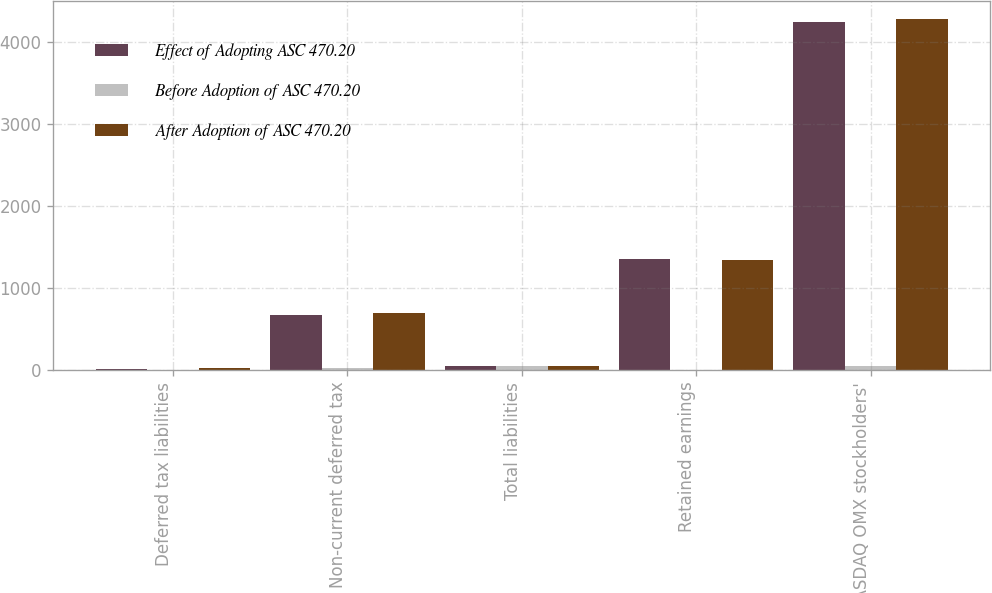Convert chart to OTSL. <chart><loc_0><loc_0><loc_500><loc_500><stacked_bar_chart><ecel><fcel>Deferred tax liabilities<fcel>Non-current deferred tax<fcel>Total liabilities<fcel>Retained earnings<fcel>Total NASDAQ OMX stockholders'<nl><fcel>Effect of Adopting ASC 470.20<fcel>14<fcel>672<fcel>45<fcel>1350<fcel>4241<nl><fcel>Before Adoption of ASC 470.20<fcel>5<fcel>24<fcel>45<fcel>6<fcel>45<nl><fcel>After Adoption of ASC 470.20<fcel>19<fcel>696<fcel>45<fcel>1344<fcel>4286<nl></chart> 